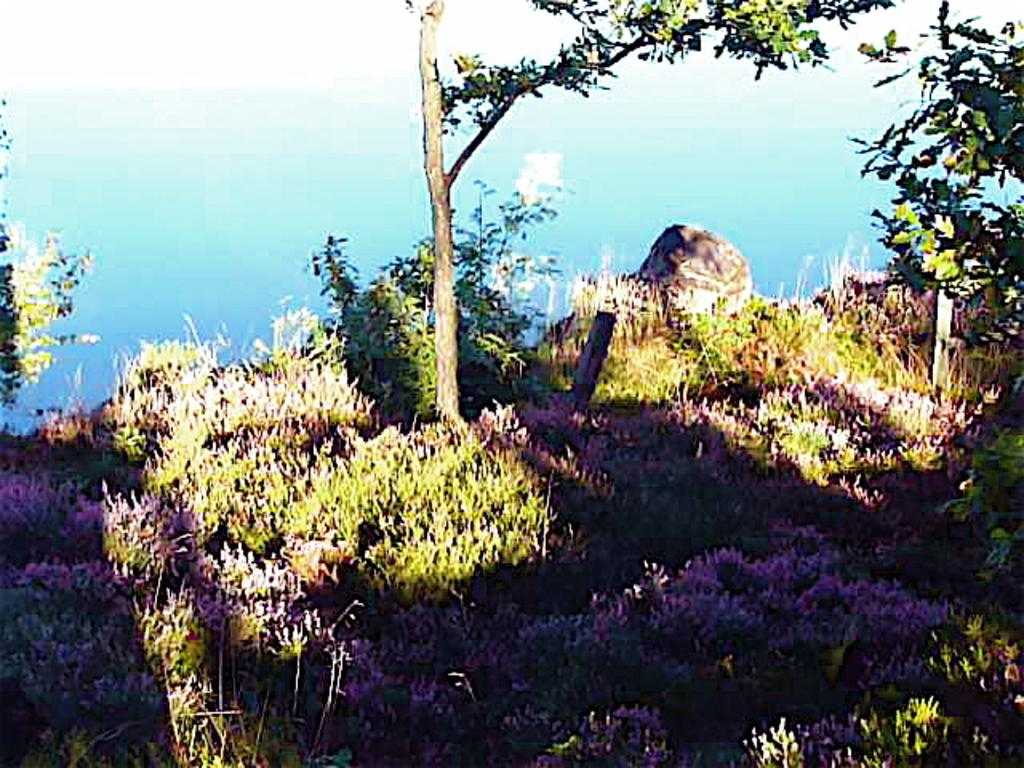What type of living organisms can be seen in the image? Plants and trees are visible in the image. What color are the plants and trees in the image? The plants and trees are in green color. What can be seen in the background of the image? There is water visible in the background of the image. What is the color of the sky in the image? The sky is white in color. What type of comb is used to style the skirt in the image? There is no comb or skirt present in the image; it features plants and trees with a green color, water in the background, and a white sky. 